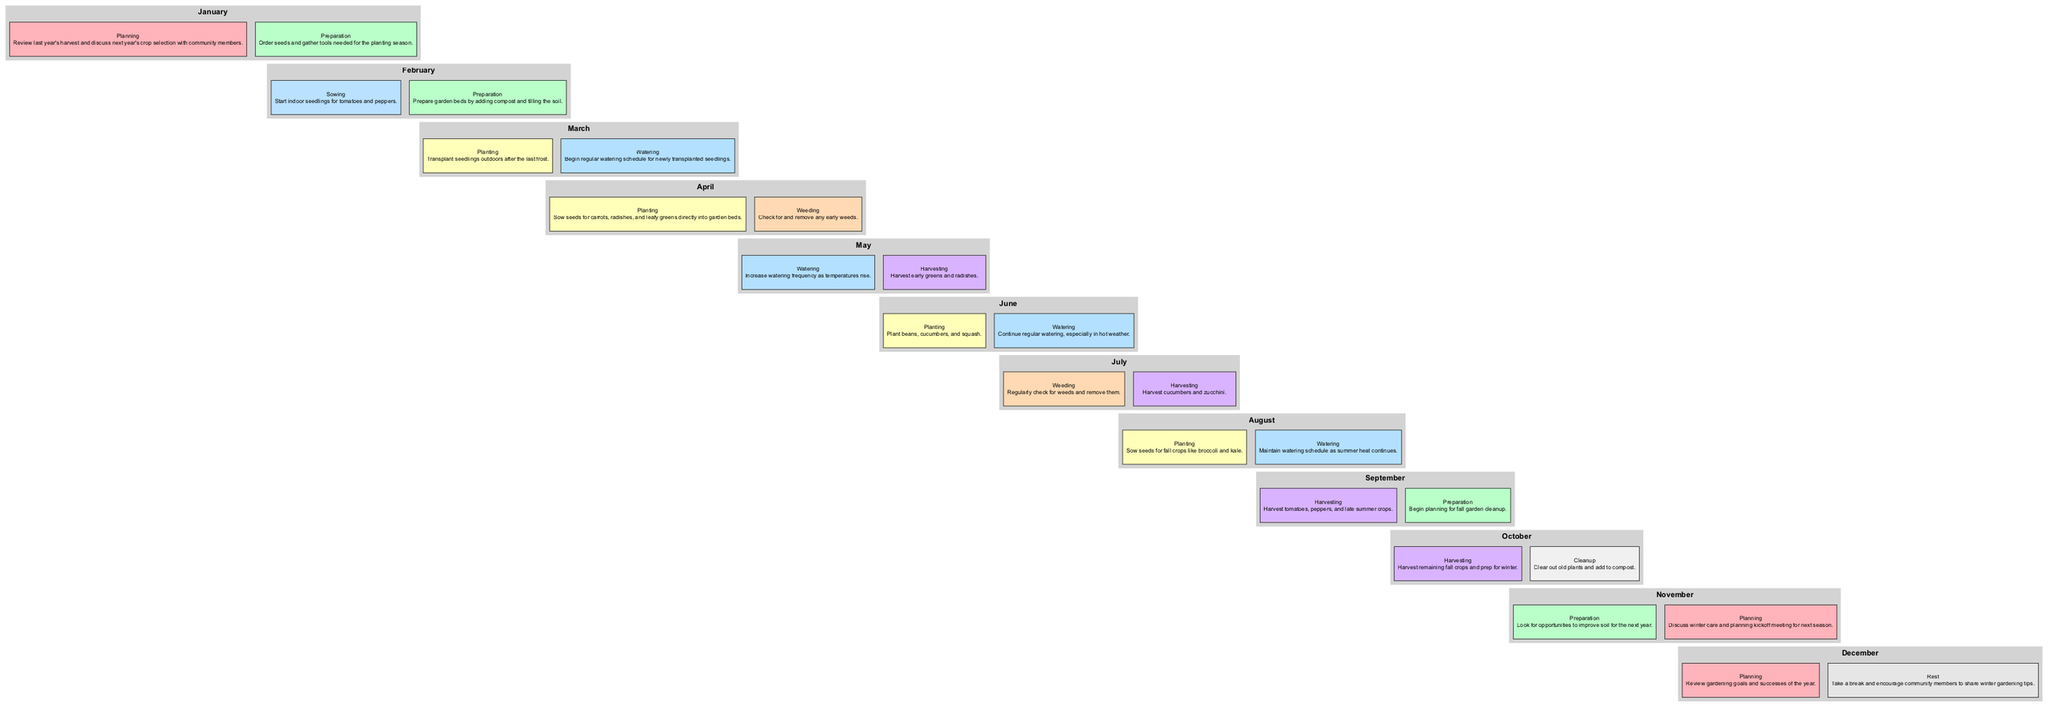What tasks are planned for January? In January, the tasks include "Review last year's harvest and discuss next year's crop selection with community members" and "Order seeds and gather tools needed for the planting season."
Answer: Planning and Preparation Which month involves weeding? Weeding tasks are scheduled in April, specifically "Check for and remove any early weeds," and also in July with "Regularly check for weeds and remove them."
Answer: April and July What is the first task type in March? The first task in March is "Transplant seedlings outdoors after the last frost," which is categorized as "Planting."
Answer: Planting How many months include harvesting tasks? Harvesting tasks occur in May, July, September, and October, making a total of four months that include harvesting tasks.
Answer: Four What is the color associated with the "Watering" tasks in the diagram? In the diagram, "Watering" tasks are represented by the color light blue. This can be identified in the diagram's color coding scheme for tasks.
Answer: Light blue Which task occurs in August? In August, the tasks include "Sow seeds for fall crops like broccoli and kale" for planting and "Maintain watering schedule as summer heat continues" for watering. Both tasks are listed under the tasks for that month.
Answer: Planting and Watering What task type appears last in October? The last task listed in October is the "Cleanup" with details of "Clear out old plants and add to compost." This task comes after the harvesting tasks.
Answer: Cleanup 